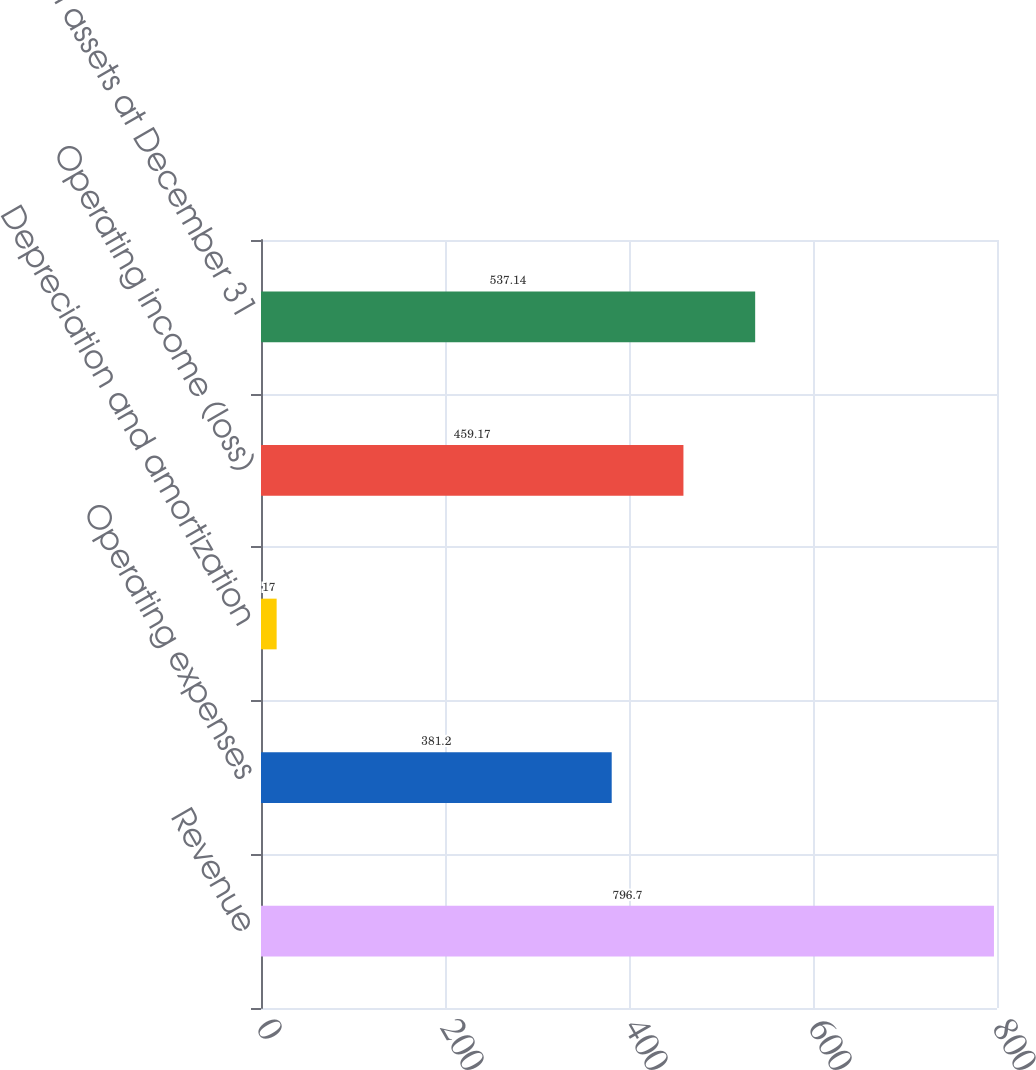<chart> <loc_0><loc_0><loc_500><loc_500><bar_chart><fcel>Revenue<fcel>Operating expenses<fcel>Depreciation and amortization<fcel>Operating income (loss)<fcel>Total assets at December 31<nl><fcel>796.7<fcel>381.2<fcel>17<fcel>459.17<fcel>537.14<nl></chart> 